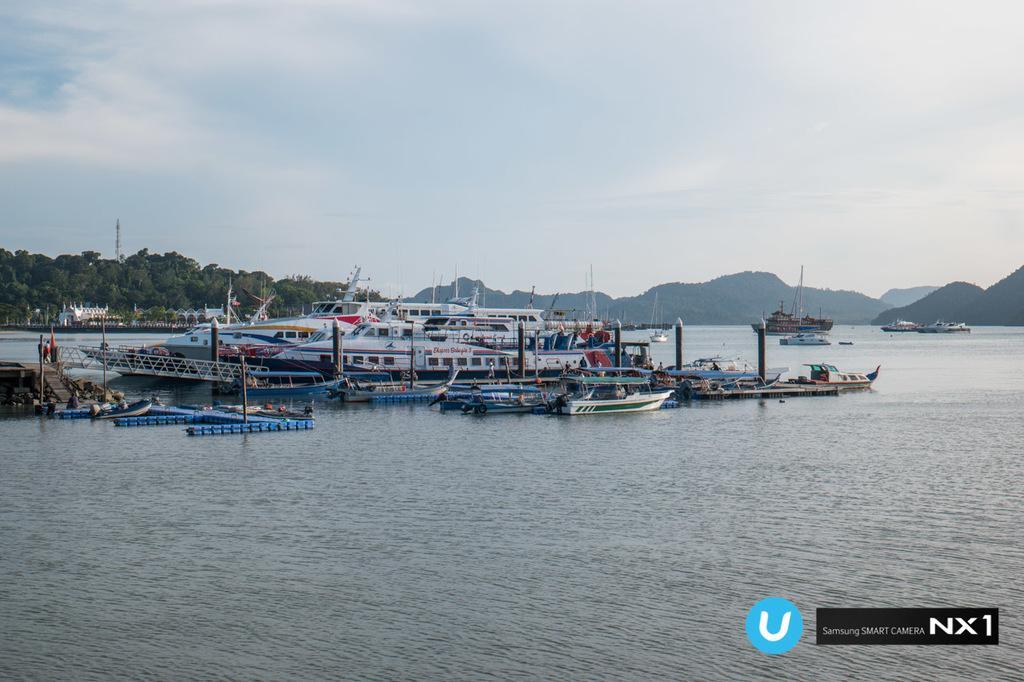Describe this image in one or two sentences. In this image we can see ships and boats on the water, trees, buildings, tower, hills and sky with clouds. 